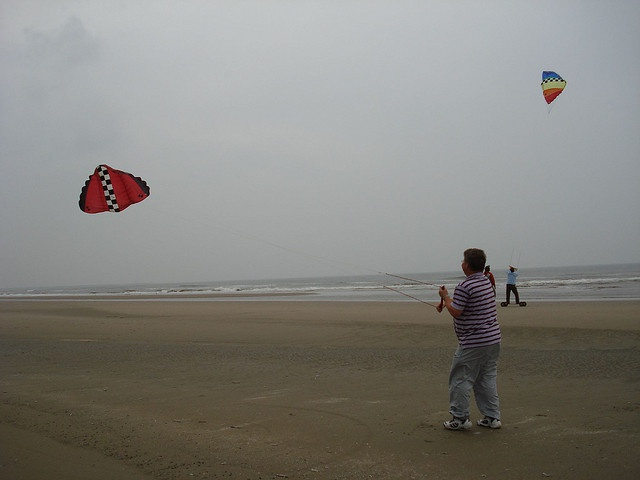Describe the objects in this image and their specific colors. I can see people in darkgray, black, gray, and maroon tones, kite in darkgray, maroon, and black tones, kite in darkgray, olive, maroon, and brown tones, people in darkgray, black, and gray tones, and people in darkgray, black, maroon, and gray tones in this image. 